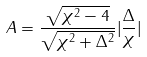<formula> <loc_0><loc_0><loc_500><loc_500>A = \frac { \sqrt { \chi ^ { 2 } - 4 } } { \sqrt { \chi ^ { 2 } + \Delta ^ { 2 } } } | \frac { \Delta } { \chi } |</formula> 